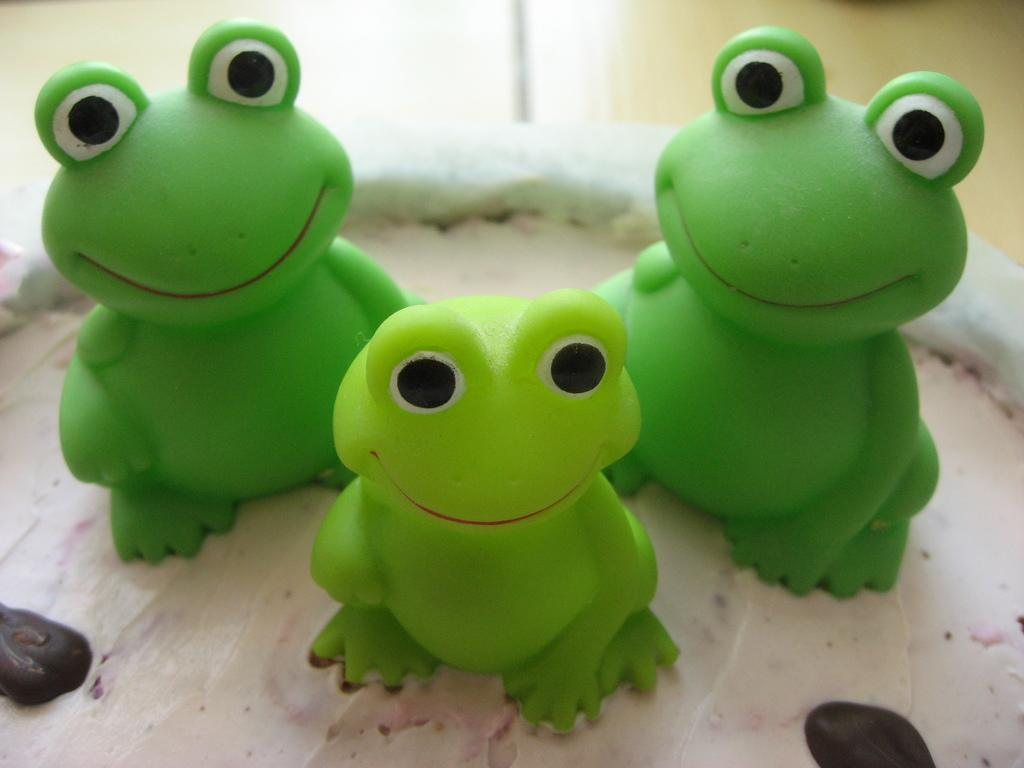What objects are present in the image? There are toys in the image. What is the toys placed on? The toys are on a food item. What color are the toys? The toys are green in color. Can you describe the background of the image? The background of the image is blurred. What type of mountain can be seen in the background of the image? There is no mountain present in the image; the background is blurred. What songs are being sung by the toys in the image? The toys in the image are not singing songs; they are simply toys placed on a food item. 